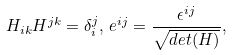<formula> <loc_0><loc_0><loc_500><loc_500>H _ { i k } H ^ { j k } = \delta _ { i } ^ { j } , \, e ^ { i j } = \frac { \epsilon ^ { i j } } { \sqrt { d e t ( H ) } } ,</formula> 